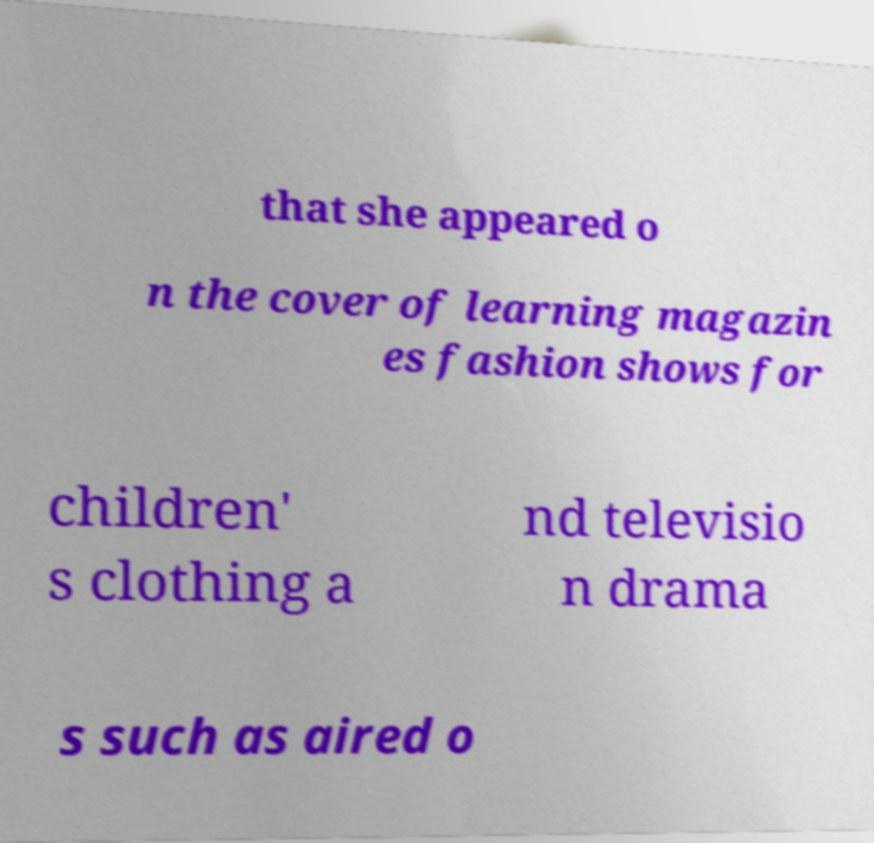Can you read and provide the text displayed in the image?This photo seems to have some interesting text. Can you extract and type it out for me? that she appeared o n the cover of learning magazin es fashion shows for children' s clothing a nd televisio n drama s such as aired o 